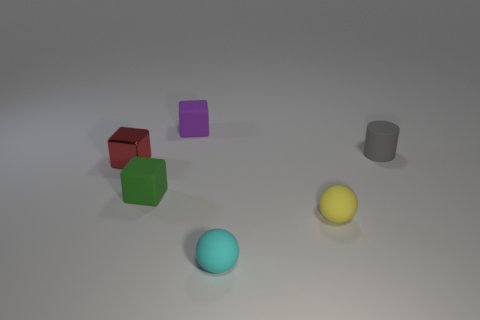Add 2 gray matte objects. How many objects exist? 8 Subtract all cylinders. How many objects are left? 5 Add 3 green cylinders. How many green cylinders exist? 3 Subtract 0 yellow cubes. How many objects are left? 6 Subtract all small cyan rubber balls. Subtract all small matte things. How many objects are left? 0 Add 2 small gray matte things. How many small gray matte things are left? 3 